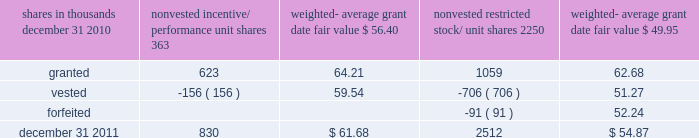There were no options granted in excess of market value in 2011 , 2010 or 2009 .
Shares of common stock available during the next year for the granting of options and other awards under the incentive plans were 33775543 at december 31 , 2011 .
Total shares of pnc common stock authorized for future issuance under equity compensation plans totaled 35304422 shares at december 31 , 2011 , which includes shares available for issuance under the incentive plans and the employee stock purchase plan ( espp ) as described below .
During 2011 , we issued 731336 shares from treasury stock in connection with stock option exercise activity .
As with past exercise activity , we currently intend to utilize primarily treasury stock for any future stock option exercises .
Awards granted to non-employee directors in 2011 , 2010 and 2009 include 27090 , 29040 , and 39552 deferred stock units , respectively , awarded under the outside directors deferred stock unit plan .
A deferred stock unit is a phantom share of our common stock , which requires liability accounting treatment until such awards are paid to the participants as cash .
As there are no vesting or service requirements on these awards , total compensation expense is recognized in full on awarded deferred stock units on the date of grant .
Incentive/performance unit share awards and restricted stock/unit awards the fair value of nonvested incentive/performance unit share awards and restricted stock/unit awards is initially determined based on prices not less than the market value of our common stock price on the date of grant .
The value of certain incentive/ performance unit share awards is subsequently remeasured based on the achievement of one or more financial and other performance goals generally over a three-year period .
The personnel and compensation committee of the board of directors approves the final award payout with respect to incentive/performance unit share awards .
Restricted stock/unit awards have various vesting periods generally ranging from 36 months to 60 months .
Beginning in 2011 , we incorporated two changes to certain awards under our existing long-term incentive compensation programs .
First , for certain grants of incentive performance units , the future payout amount will be subject to a negative annual adjustment if pnc fails to meet certain risk-related performance metrics .
This adjustment is in addition to the existing financial performance metrics relative to our peers .
These grants have a three-year performance period and are payable in either stock or a combination of stock and cash .
Second , performance-based restricted share units ( performance rsus ) were granted in 2011 to certain of our executives in lieu of stock options .
These performance rsus ( which are payable solely in stock ) have a service condition , an internal risk-related performance condition , and an external market condition .
Satisfaction of the performance condition is based on four independent one-year performance periods .
The weighted-average grant-date fair value of incentive/ performance unit share awards and restricted stock/unit awards granted in 2011 , 2010 and 2009 was $ 63.25 , $ 54.59 and $ 41.16 per share , respectively .
We recognize compensation expense for such awards ratably over the corresponding vesting and/or performance periods for each type of program .
Nonvested incentive/performance unit share awards and restricted stock/unit awards 2013 rollforward shares in thousands nonvested incentive/ performance unit shares weighted- average date fair nonvested restricted stock/ shares weighted- average date fair .
In the chart above , the unit shares and related weighted- average grant-date fair value of the incentive/performance awards exclude the effect of dividends on the underlying shares , as those dividends will be paid in cash .
At december 31 , 2011 , there was $ 61 million of unrecognized deferred compensation expense related to nonvested share- based compensation arrangements granted under the incentive plans .
This cost is expected to be recognized as expense over a period of no longer than five years .
The total fair value of incentive/performance unit share and restricted stock/unit awards vested during 2011 , 2010 and 2009 was approximately $ 52 million , $ 39 million and $ 47 million , respectively .
Liability awards we grant annually cash-payable restricted share units to certain executives .
The grants were made primarily as part of an annual bonus incentive deferral plan .
While there are time- based and service-related vesting criteria , there are no market or performance criteria associated with these awards .
Compensation expense recognized related to these awards was recorded in prior periods as part of annual cash bonus criteria .
As of december 31 , 2011 , there were 753203 of these cash- payable restricted share units outstanding .
174 the pnc financial services group , inc .
2013 form 10-k .
What was the percentage change in the total fair value of incentive/performance unit share and restricted stock/unit awards from 2010 to 2011,? 
Computations: ((52 + 39) / 39)
Answer: 2.33333. 